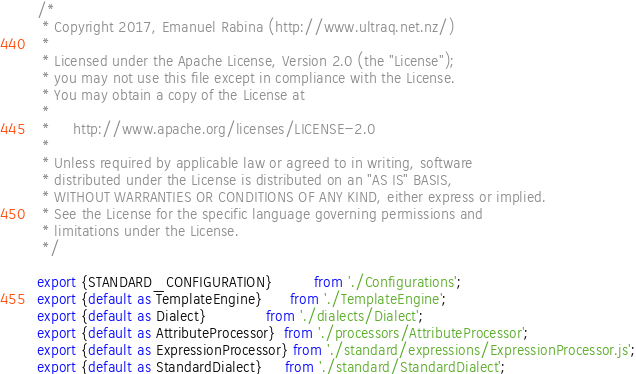Convert code to text. <code><loc_0><loc_0><loc_500><loc_500><_JavaScript_>/* 
 * Copyright 2017, Emanuel Rabina (http://www.ultraq.net.nz/)
 * 
 * Licensed under the Apache License, Version 2.0 (the "License");
 * you may not use this file except in compliance with the License.
 * You may obtain a copy of the License at
 * 
 *     http://www.apache.org/licenses/LICENSE-2.0
 * 
 * Unless required by applicable law or agreed to in writing, software
 * distributed under the License is distributed on an "AS IS" BASIS,
 * WITHOUT WARRANTIES OR CONDITIONS OF ANY KIND, either express or implied.
 * See the License for the specific language governing permissions and
 * limitations under the License.
 */

export {STANDARD_CONFIGURATION}         from './Configurations';
export {default as TemplateEngine}      from './TemplateEngine';
export {default as Dialect}             from './dialects/Dialect';
export {default as AttributeProcessor}  from './processors/AttributeProcessor';
export {default as ExpressionProcessor} from './standard/expressions/ExpressionProcessor.js';
export {default as StandardDialect}     from './standard/StandardDialect';
</code> 